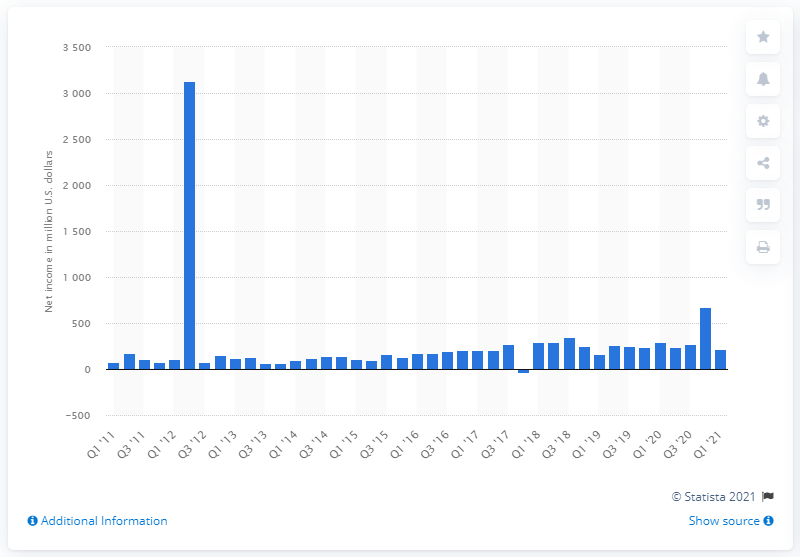Outline some significant characteristics in this image. In the first quarter of 2021, the net income of SiriusXM Holdings was $219 million. SiriusXM Holdings reported a net income of $293 million in the first quarter of 2021. 